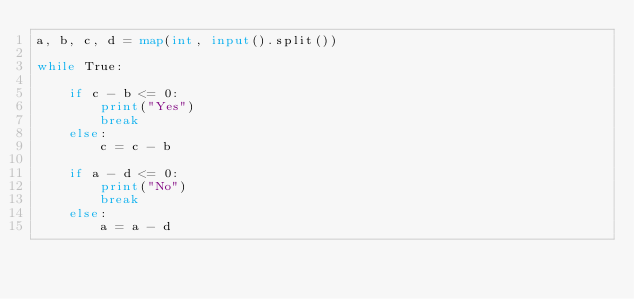<code> <loc_0><loc_0><loc_500><loc_500><_Python_>a, b, c, d = map(int, input().split())

while True:

    if c - b <= 0:
        print("Yes")
        break
    else:
        c = c - b

    if a - d <= 0:
        print("No")
        break
    else:
        a = a - d
</code> 